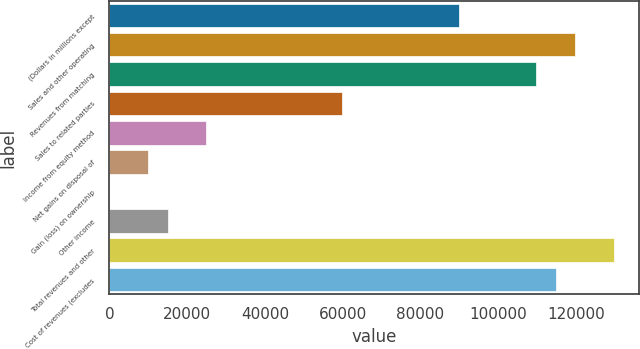<chart> <loc_0><loc_0><loc_500><loc_500><bar_chart><fcel>(Dollars in millions except<fcel>Sales and other operating<fcel>Revenues from matching<fcel>Sales to related parties<fcel>Income from equity method<fcel>Net gains on disposal of<fcel>Gain (loss) on ownership<fcel>Other income<fcel>Total revenues and other<fcel>Cost of revenues (excludes<nl><fcel>89831<fcel>119774<fcel>109793<fcel>59888<fcel>24954.5<fcel>9983<fcel>2<fcel>14973.5<fcel>129755<fcel>114784<nl></chart> 